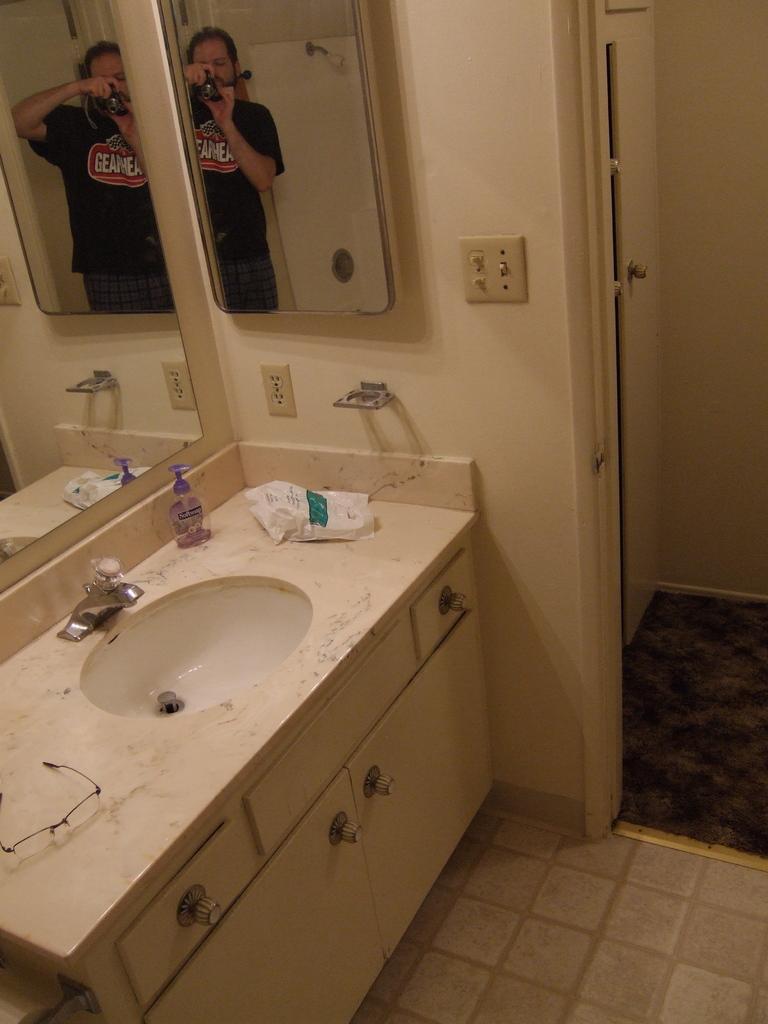In one or two sentences, can you explain what this image depicts? In this image, we can see a wash basin with some objects like spectacles. We can also see some cupboards and mirrors. We can see the wall with some objects. We can also see a door and the ground. We can see the reflection of objects and person in the mirrors. 